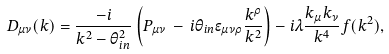<formula> <loc_0><loc_0><loc_500><loc_500>D _ { \mu \nu } ( k ) = \frac { - i } { k ^ { 2 } - \theta ^ { 2 } _ { i n } } \left ( P _ { \mu \nu } \, - \, i \theta _ { i n } \epsilon _ { \mu \nu \rho } \frac { k ^ { \rho } } { k ^ { 2 } } \right ) - i \lambda \frac { k _ { \mu } k _ { \nu } } { k ^ { 4 } } f ( k ^ { 2 } ) ,</formula> 